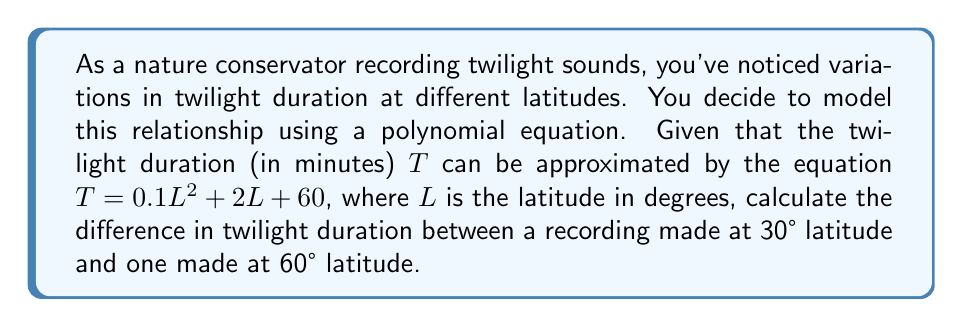What is the answer to this math problem? To solve this problem, we need to follow these steps:

1) First, let's calculate the twilight duration at 30° latitude:
   
   $T_{30} = 0.1(30)^2 + 2(30) + 60$
   $T_{30} = 0.1(900) + 60 + 60$
   $T_{30} = 90 + 60 + 60$
   $T_{30} = 210$ minutes

2) Now, let's calculate the twilight duration at 60° latitude:
   
   $T_{60} = 0.1(60)^2 + 2(60) + 60$
   $T_{60} = 0.1(3600) + 120 + 60$
   $T_{60} = 360 + 120 + 60$
   $T_{60} = 540$ minutes

3) To find the difference, we subtract the duration at 30° from the duration at 60°:

   $\text{Difference} = T_{60} - T_{30}$
   $\text{Difference} = 540 - 210$
   $\text{Difference} = 330$ minutes

Therefore, the difference in twilight duration between 30° and 60° latitude is 330 minutes.
Answer: 330 minutes 